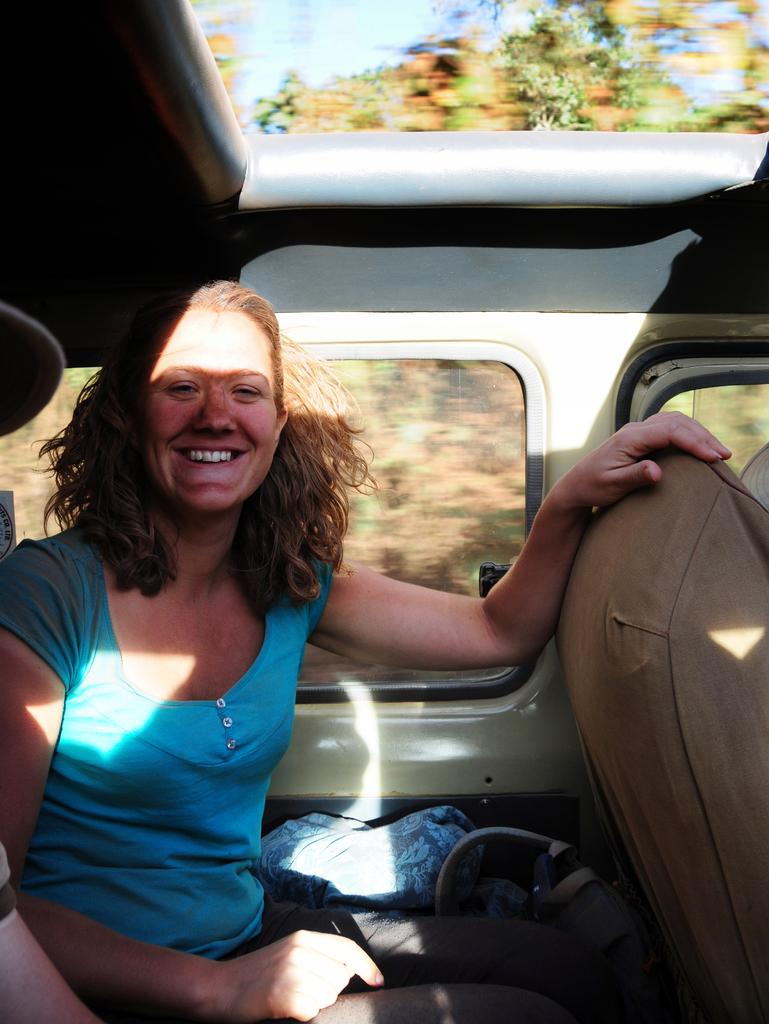Who is present in the image? There is a woman in the image. What is the woman doing in the image? The woman is sitting in a vehicle. What is the woman's facial expression in the image? The woman is smiling. What can be seen in the background of the image? There are trees visible in the background of the image. What type of distribution system is visible in the image? There is no distribution system present in the image. How does the woman mark her territory in the image? The woman is not marking her territory in the image; she is simply sitting in a vehicle and smiling. 